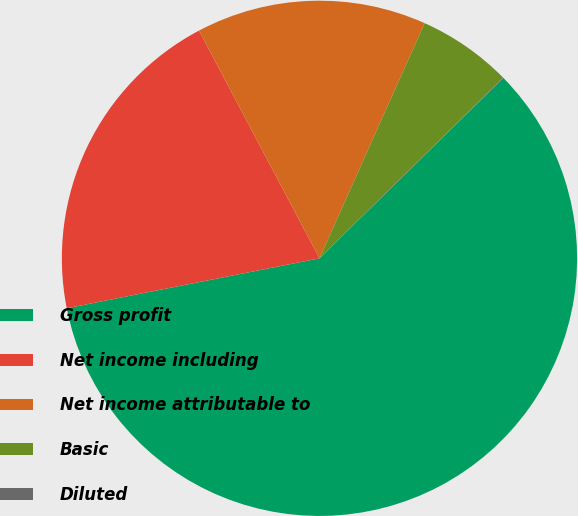<chart> <loc_0><loc_0><loc_500><loc_500><pie_chart><fcel>Gross profit<fcel>Net income including<fcel>Net income attributable to<fcel>Basic<fcel>Diluted<nl><fcel>59.24%<fcel>20.36%<fcel>14.44%<fcel>5.94%<fcel>0.02%<nl></chart> 